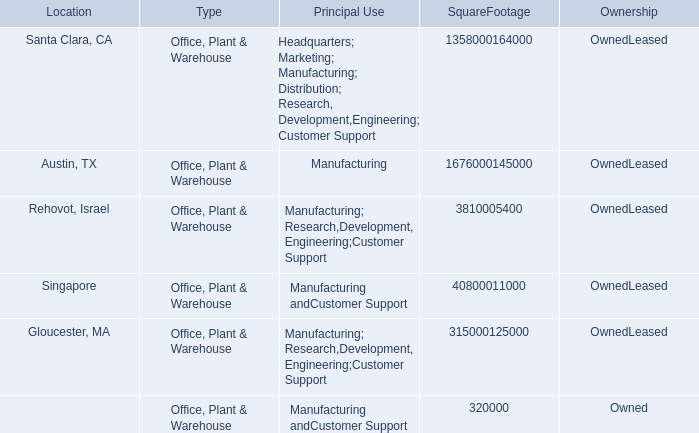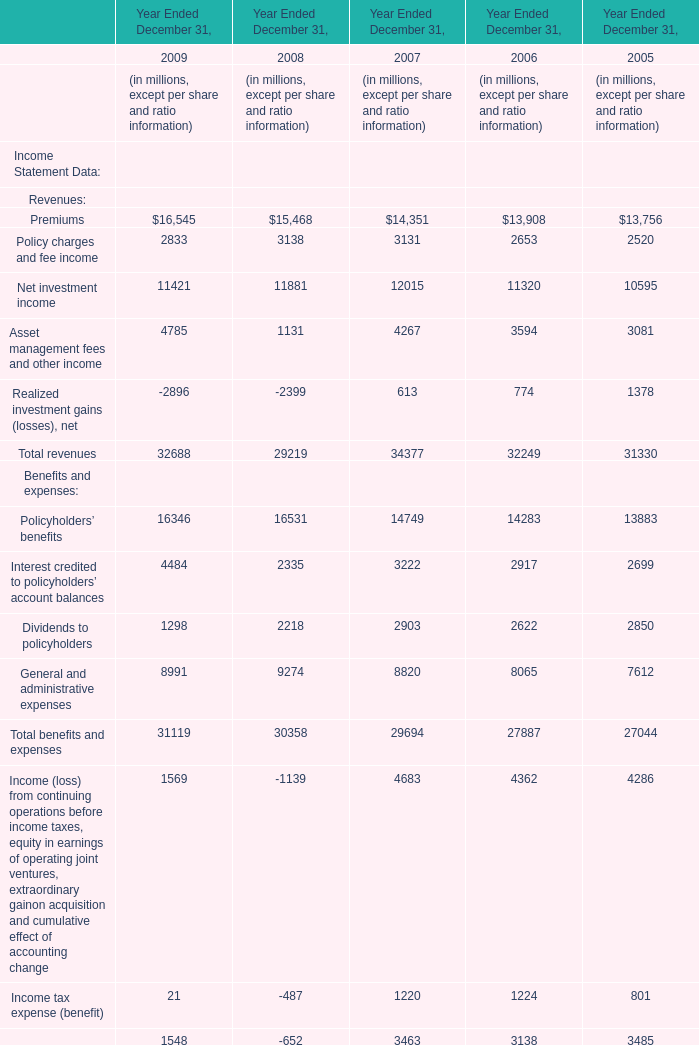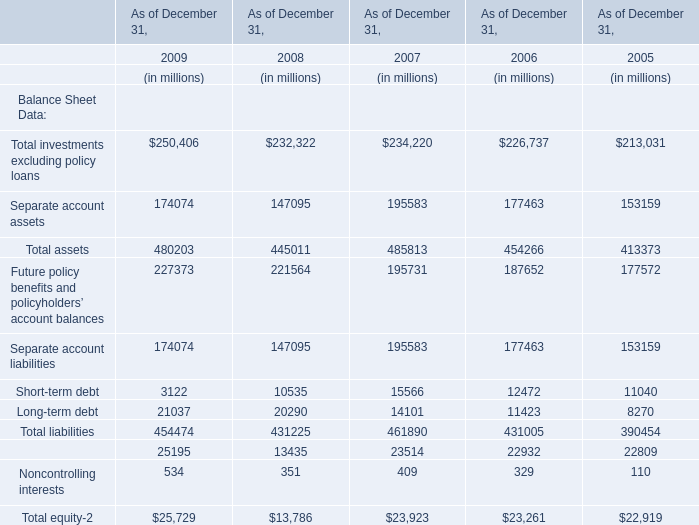In the year with the most Net investment income , what is the growth rate of Asset management fees and other income? 
Computations: ((4267 - 3594) / 3594)
Answer: 0.18726. 